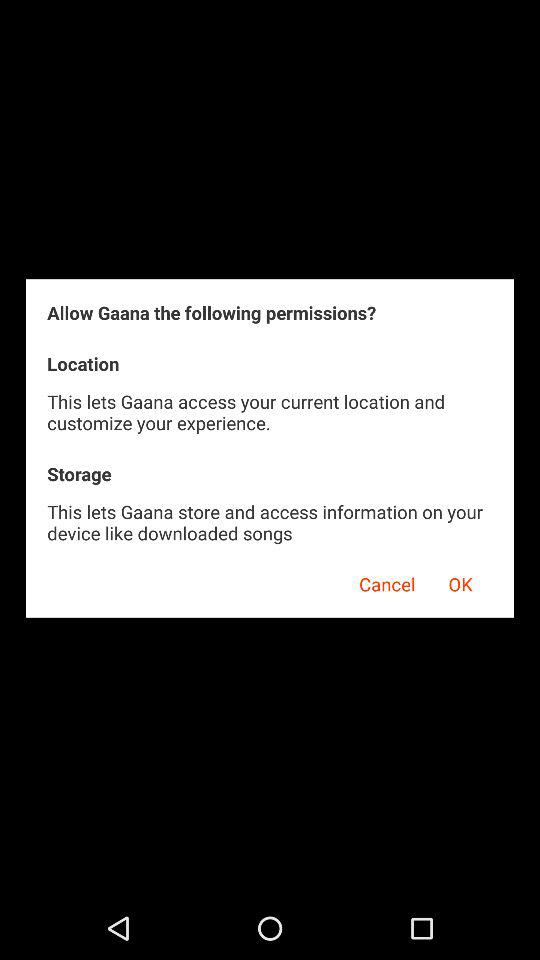How many permissions are being requested?
Answer the question using a single word or phrase. 2 